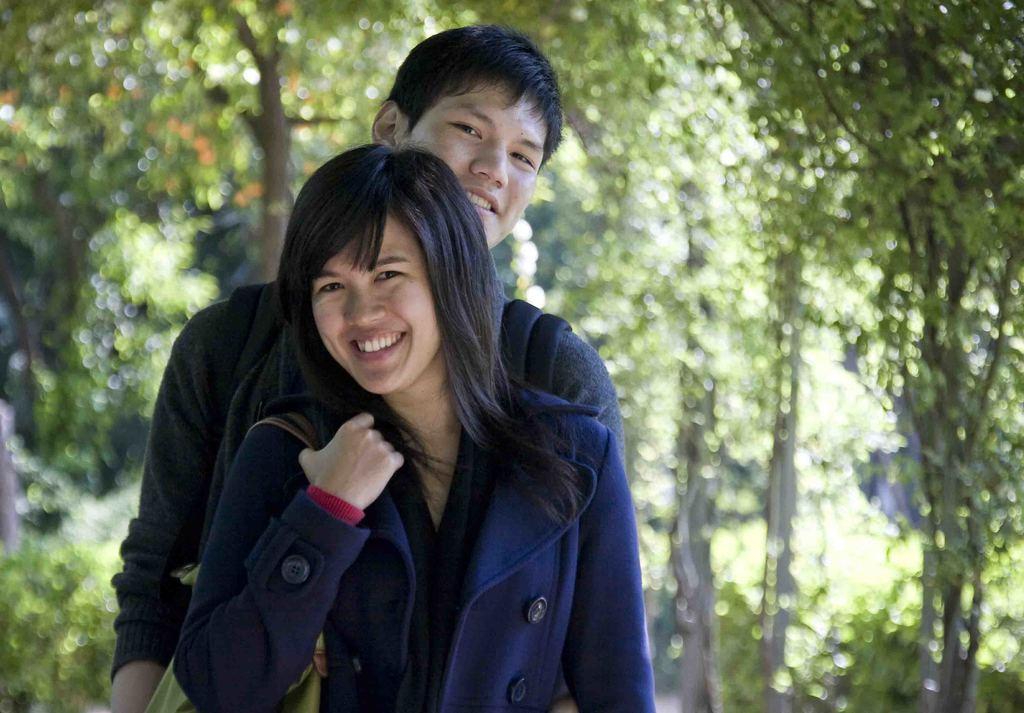Can you describe this image briefly? There is a boy and a girl standing in the foreground area and greenery in the background area. 